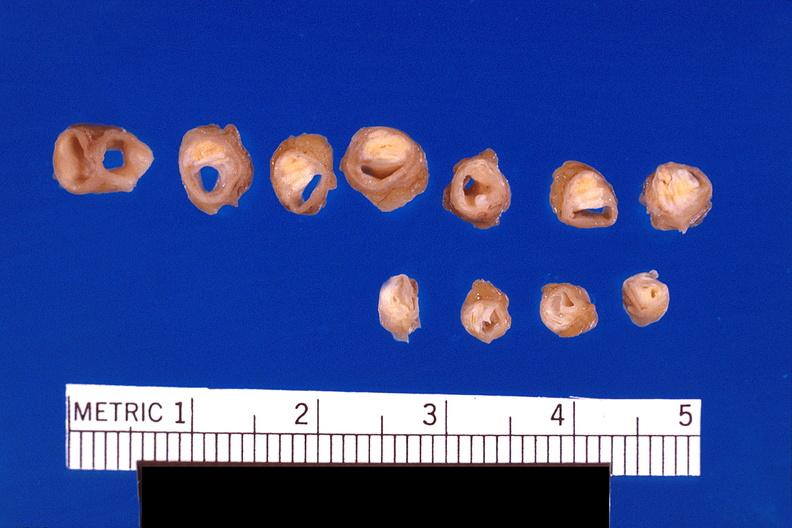what is present?
Answer the question using a single word or phrase. Cardiovascular 